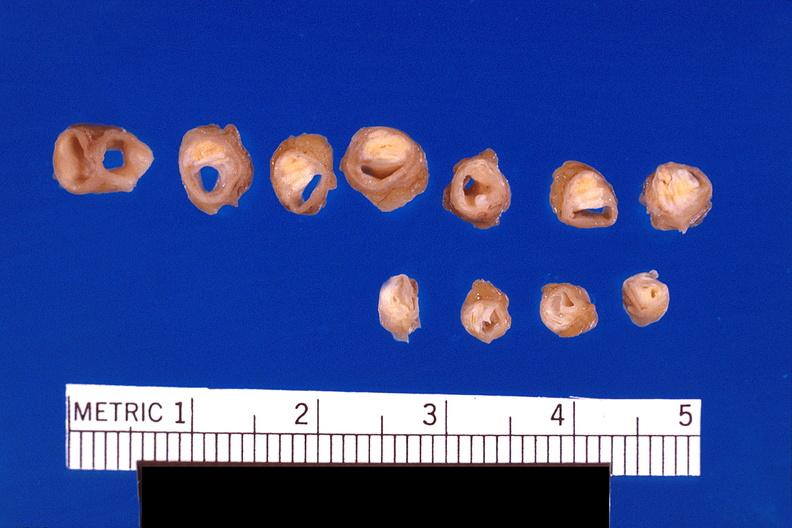what is present?
Answer the question using a single word or phrase. Cardiovascular 